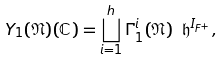<formula> <loc_0><loc_0><loc_500><loc_500>Y _ { 1 } ( \mathfrak { N } ) ( \mathbb { C } ) = \bigsqcup _ { i = 1 } ^ { h } \Gamma _ { 1 } ^ { i } ( \mathfrak { N } ) \ \mathfrak { h } ^ { I _ { F ^ { + } } } ,</formula> 